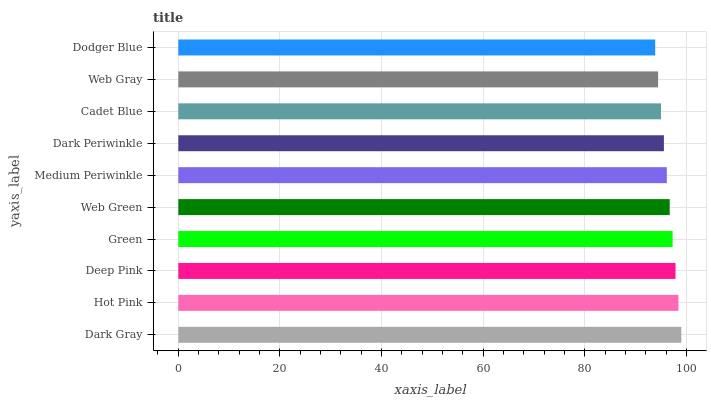Is Dodger Blue the minimum?
Answer yes or no. Yes. Is Dark Gray the maximum?
Answer yes or no. Yes. Is Hot Pink the minimum?
Answer yes or no. No. Is Hot Pink the maximum?
Answer yes or no. No. Is Dark Gray greater than Hot Pink?
Answer yes or no. Yes. Is Hot Pink less than Dark Gray?
Answer yes or no. Yes. Is Hot Pink greater than Dark Gray?
Answer yes or no. No. Is Dark Gray less than Hot Pink?
Answer yes or no. No. Is Web Green the high median?
Answer yes or no. Yes. Is Medium Periwinkle the low median?
Answer yes or no. Yes. Is Hot Pink the high median?
Answer yes or no. No. Is Web Gray the low median?
Answer yes or no. No. 